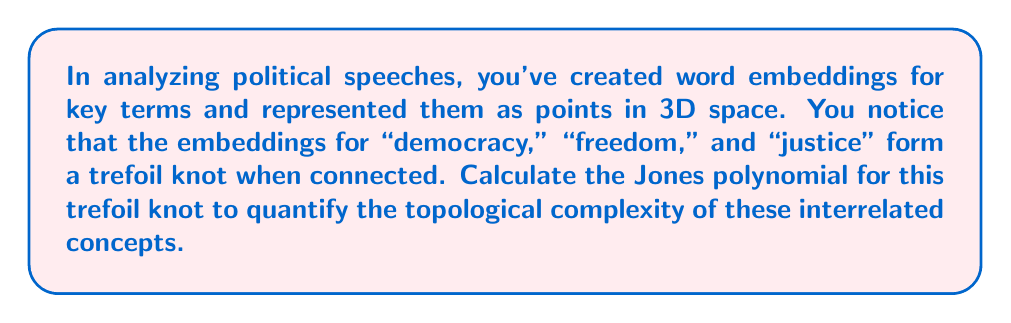What is the answer to this math problem? To calculate the Jones polynomial for the trefoil knot, we'll follow these steps:

1) The Jones polynomial for a trefoil knot is given by:

   $$V(t) = t + t^3 - t^4$$

2) However, we need to normalize this polynomial. The normalization factor for a trefoil knot is $(-t^{\frac{3}{4}})^{-3}$ because the trefoil has a writhe of 3.

3) Let's apply the normalization:

   $$V_{normalized}(t) = (-t^{\frac{3}{4}})^{-3} \cdot (t + t^3 - t^4)$$

4) Simplify the normalization factor:

   $$(-t^{\frac{3}{4}})^{-3} = -t^{-\frac{9}{4}}$$

5) Multiply this by the original polynomial:

   $$V_{normalized}(t) = -t^{-\frac{9}{4}} \cdot (t + t^3 - t^4)$$

6) Distribute the $-t^{-\frac{9}{4}}$:

   $$V_{normalized}(t) = -t^{-\frac{5}{4}} - t^{\frac{3}{4}} + t^{\frac{7}{4}}$$

This normalized Jones polynomial quantifies the topological complexity of the relationship between "democracy," "freedom," and "justice" in the analyzed political speeches.
Answer: $-t^{-\frac{5}{4}} - t^{\frac{3}{4}} + t^{\frac{7}{4}}$ 